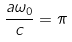Convert formula to latex. <formula><loc_0><loc_0><loc_500><loc_500>\frac { a \omega _ { 0 } } { c } = \pi</formula> 